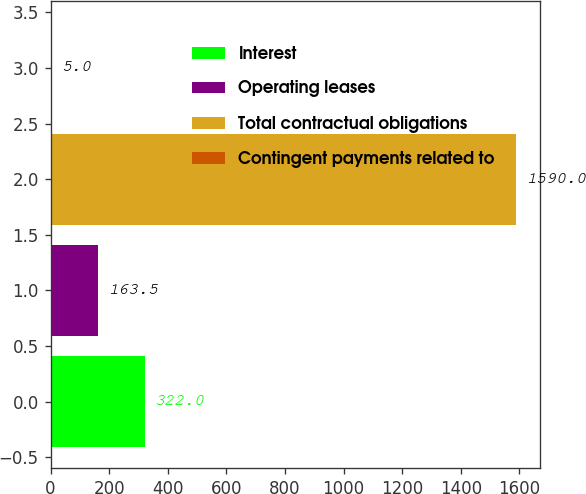<chart> <loc_0><loc_0><loc_500><loc_500><bar_chart><fcel>Interest<fcel>Operating leases<fcel>Total contractual obligations<fcel>Contingent payments related to<nl><fcel>322<fcel>163.5<fcel>1590<fcel>5<nl></chart> 